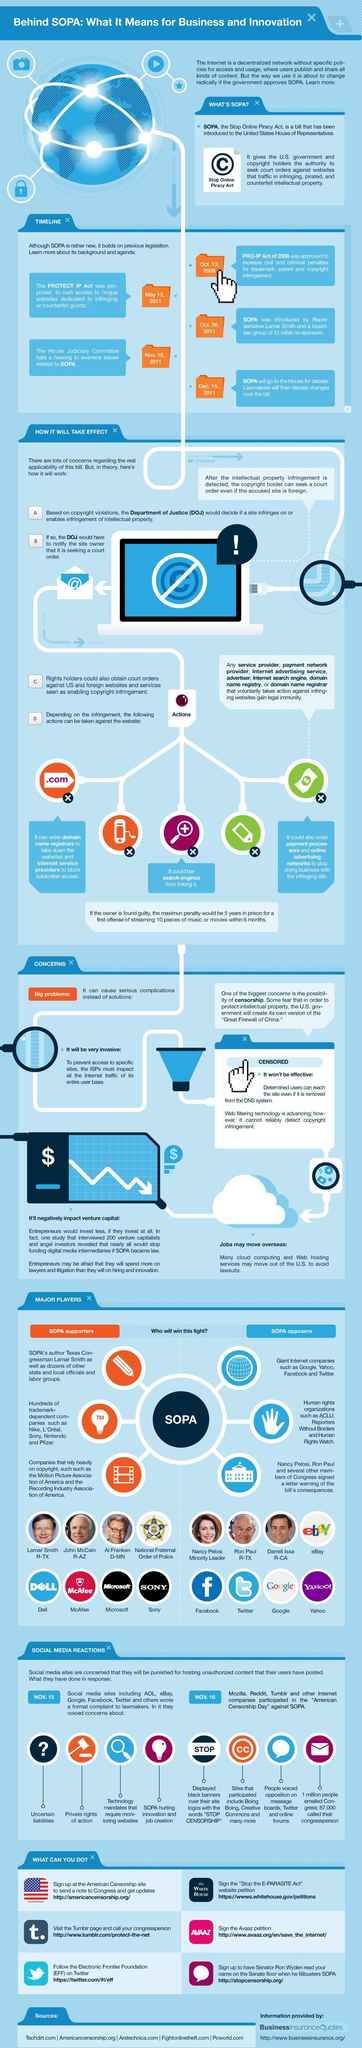What is the color code given to people who are against SOPA- yellow, blue, orange, green?
Answer the question with a short phrase. blue Which are the Internet leaders who are against SOPA? Google, Yahoo, Facebook and Twitter What is the color code given to supporters of SOPA- yellow, red, orange, green? orange 